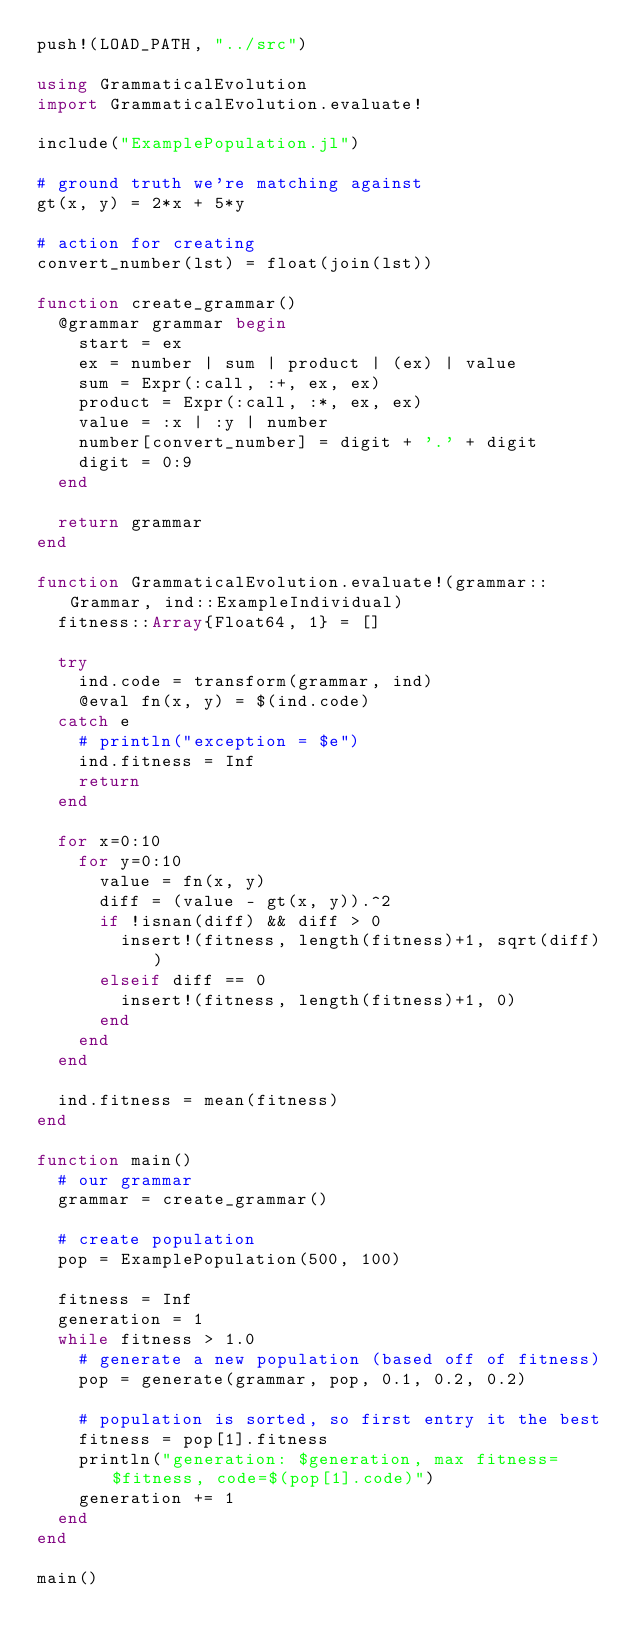<code> <loc_0><loc_0><loc_500><loc_500><_Julia_>push!(LOAD_PATH, "../src")

using GrammaticalEvolution
import GrammaticalEvolution.evaluate!

include("ExamplePopulation.jl")

# ground truth we're matching against
gt(x, y) = 2*x + 5*y

# action for creating
convert_number(lst) = float(join(lst))

function create_grammar()
  @grammar grammar begin
    start = ex
    ex = number | sum | product | (ex) | value
    sum = Expr(:call, :+, ex, ex)
    product = Expr(:call, :*, ex, ex)
    value = :x | :y | number
    number[convert_number] = digit + '.' + digit
    digit = 0:9
  end

  return grammar
end

function GrammaticalEvolution.evaluate!(grammar::Grammar, ind::ExampleIndividual)
  fitness::Array{Float64, 1} = []

  try
    ind.code = transform(grammar, ind)
    @eval fn(x, y) = $(ind.code)
  catch e
    # println("exception = $e")
    ind.fitness = Inf
    return
  end

  for x=0:10
    for y=0:10
      value = fn(x, y)
      diff = (value - gt(x, y)).^2
      if !isnan(diff) && diff > 0
        insert!(fitness, length(fitness)+1, sqrt(diff))
      elseif diff == 0
        insert!(fitness, length(fitness)+1, 0)
      end
    end
  end

  ind.fitness = mean(fitness)
end

function main()
  # our grammar
  grammar = create_grammar()

  # create population
  pop = ExamplePopulation(500, 100)

  fitness = Inf
  generation = 1
  while fitness > 1.0
    # generate a new population (based off of fitness)
    pop = generate(grammar, pop, 0.1, 0.2, 0.2)

    # population is sorted, so first entry it the best
    fitness = pop[1].fitness
    println("generation: $generation, max fitness=$fitness, code=$(pop[1].code)")
    generation += 1
  end
end

main()</code> 